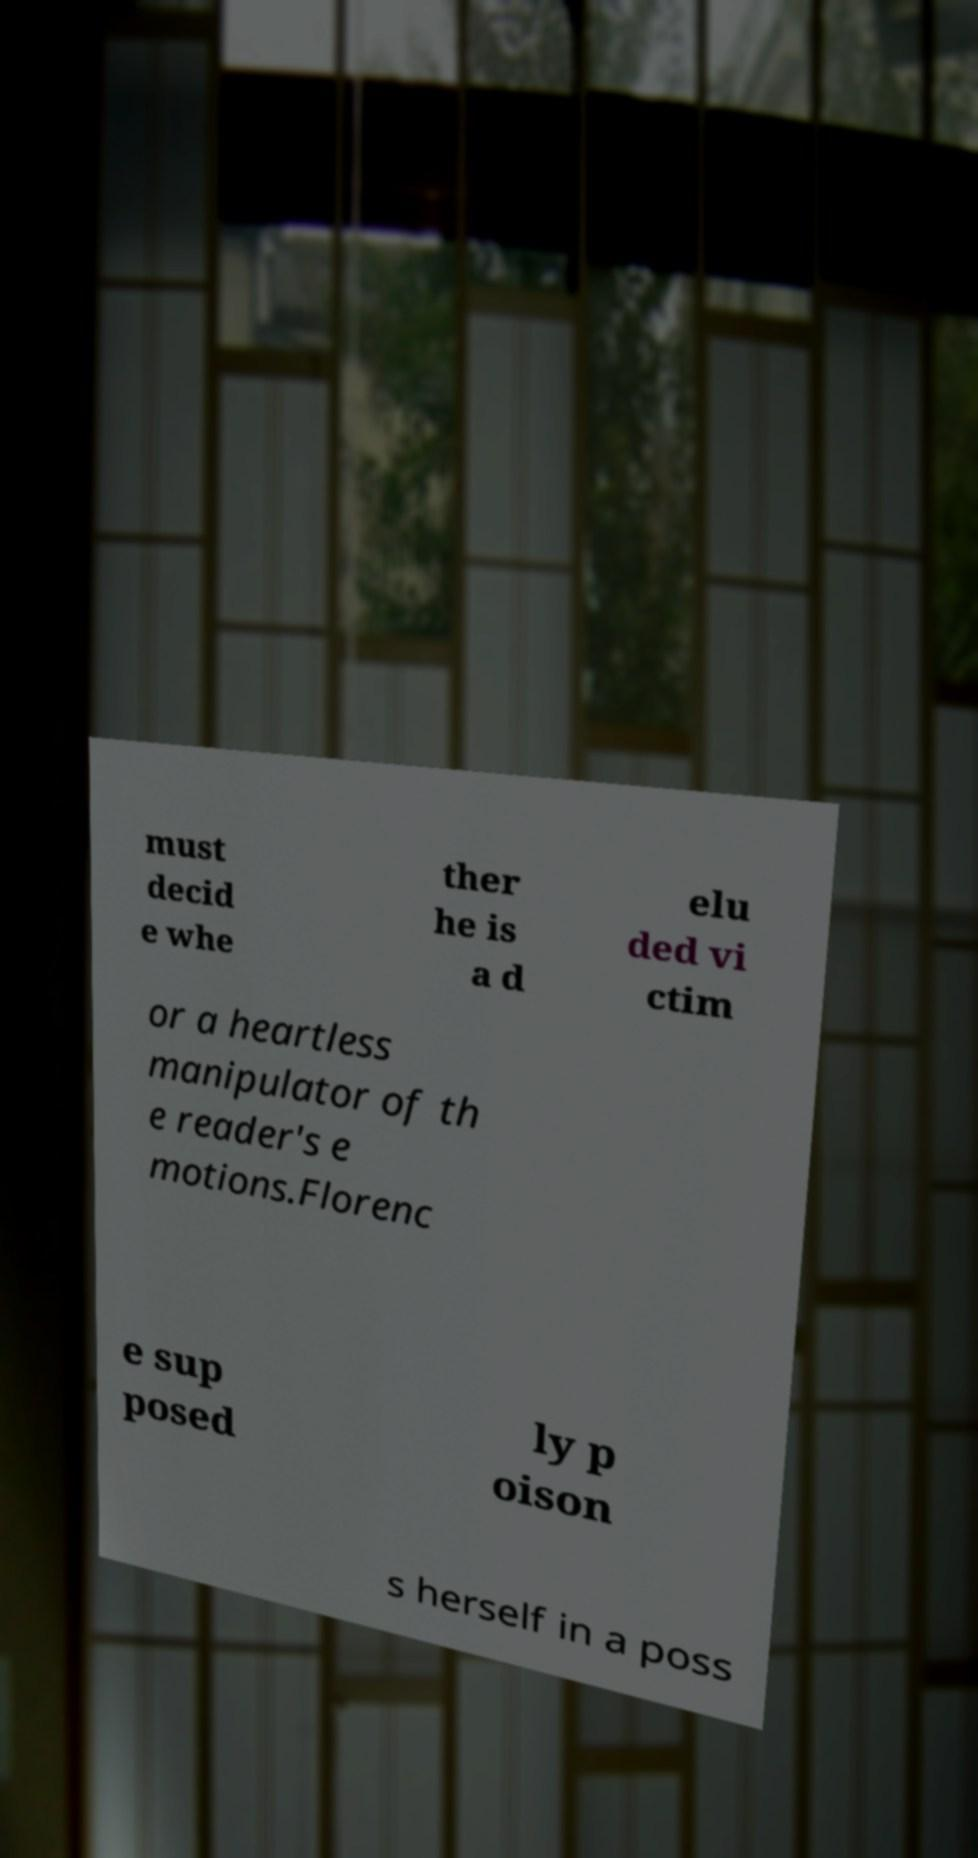Could you assist in decoding the text presented in this image and type it out clearly? must decid e whe ther he is a d elu ded vi ctim or a heartless manipulator of th e reader's e motions.Florenc e sup posed ly p oison s herself in a poss 